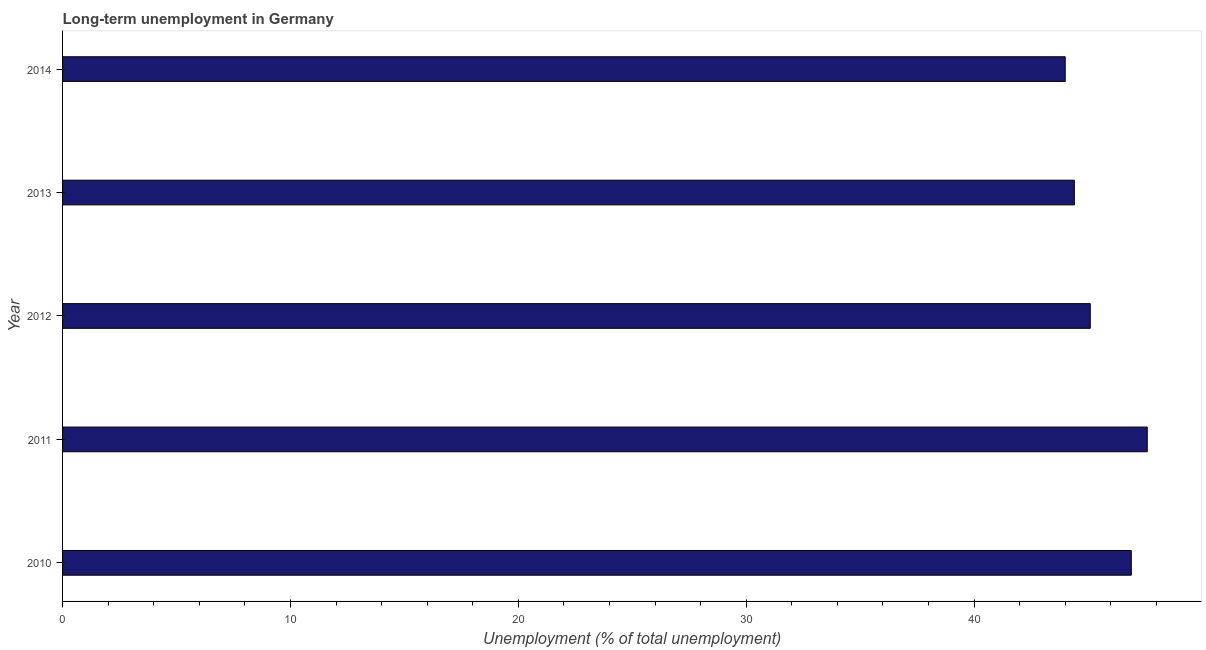Does the graph contain any zero values?
Ensure brevity in your answer.  No. Does the graph contain grids?
Give a very brief answer. No. What is the title of the graph?
Offer a terse response. Long-term unemployment in Germany. What is the label or title of the X-axis?
Provide a short and direct response. Unemployment (% of total unemployment). What is the label or title of the Y-axis?
Offer a very short reply. Year. What is the long-term unemployment in 2010?
Your answer should be very brief. 46.9. Across all years, what is the maximum long-term unemployment?
Make the answer very short. 47.6. Across all years, what is the minimum long-term unemployment?
Your response must be concise. 44. What is the sum of the long-term unemployment?
Provide a succinct answer. 228. What is the average long-term unemployment per year?
Make the answer very short. 45.6. What is the median long-term unemployment?
Give a very brief answer. 45.1. In how many years, is the long-term unemployment greater than 30 %?
Provide a short and direct response. 5. Do a majority of the years between 2014 and 2010 (inclusive) have long-term unemployment greater than 40 %?
Offer a terse response. Yes. What is the ratio of the long-term unemployment in 2010 to that in 2014?
Ensure brevity in your answer.  1.07. Is the long-term unemployment in 2011 less than that in 2014?
Offer a very short reply. No. In how many years, is the long-term unemployment greater than the average long-term unemployment taken over all years?
Offer a very short reply. 2. How many bars are there?
Your answer should be very brief. 5. Are all the bars in the graph horizontal?
Provide a succinct answer. Yes. How many years are there in the graph?
Provide a short and direct response. 5. Are the values on the major ticks of X-axis written in scientific E-notation?
Offer a very short reply. No. What is the Unemployment (% of total unemployment) of 2010?
Provide a succinct answer. 46.9. What is the Unemployment (% of total unemployment) in 2011?
Provide a succinct answer. 47.6. What is the Unemployment (% of total unemployment) of 2012?
Your response must be concise. 45.1. What is the Unemployment (% of total unemployment) of 2013?
Offer a terse response. 44.4. What is the difference between the Unemployment (% of total unemployment) in 2010 and 2013?
Offer a terse response. 2.5. What is the difference between the Unemployment (% of total unemployment) in 2011 and 2012?
Offer a very short reply. 2.5. What is the difference between the Unemployment (% of total unemployment) in 2011 and 2014?
Make the answer very short. 3.6. What is the difference between the Unemployment (% of total unemployment) in 2012 and 2013?
Ensure brevity in your answer.  0.7. What is the difference between the Unemployment (% of total unemployment) in 2012 and 2014?
Your answer should be compact. 1.1. What is the difference between the Unemployment (% of total unemployment) in 2013 and 2014?
Offer a very short reply. 0.4. What is the ratio of the Unemployment (% of total unemployment) in 2010 to that in 2011?
Offer a very short reply. 0.98. What is the ratio of the Unemployment (% of total unemployment) in 2010 to that in 2013?
Ensure brevity in your answer.  1.06. What is the ratio of the Unemployment (% of total unemployment) in 2010 to that in 2014?
Provide a succinct answer. 1.07. What is the ratio of the Unemployment (% of total unemployment) in 2011 to that in 2012?
Keep it short and to the point. 1.05. What is the ratio of the Unemployment (% of total unemployment) in 2011 to that in 2013?
Your answer should be very brief. 1.07. What is the ratio of the Unemployment (% of total unemployment) in 2011 to that in 2014?
Provide a short and direct response. 1.08. What is the ratio of the Unemployment (% of total unemployment) in 2012 to that in 2014?
Offer a terse response. 1.02. What is the ratio of the Unemployment (% of total unemployment) in 2013 to that in 2014?
Provide a succinct answer. 1.01. 